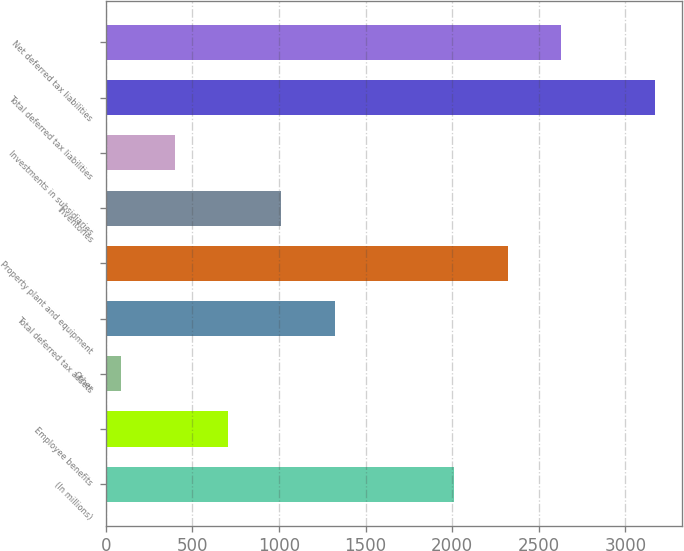<chart> <loc_0><loc_0><loc_500><loc_500><bar_chart><fcel>(In millions)<fcel>Employee benefits<fcel>Other<fcel>Total deferred tax assets<fcel>Property plant and equipment<fcel>Inventories<fcel>Investments in subsidiaries<fcel>Total deferred tax liabilities<fcel>Net deferred tax liabilities<nl><fcel>2012<fcel>706.2<fcel>90<fcel>1322.4<fcel>2320.1<fcel>1014.3<fcel>398.1<fcel>3171<fcel>2628.2<nl></chart> 